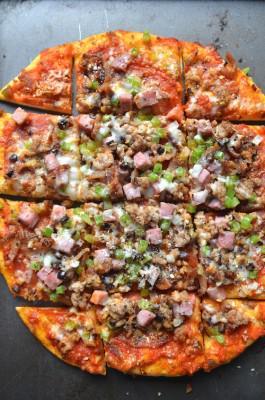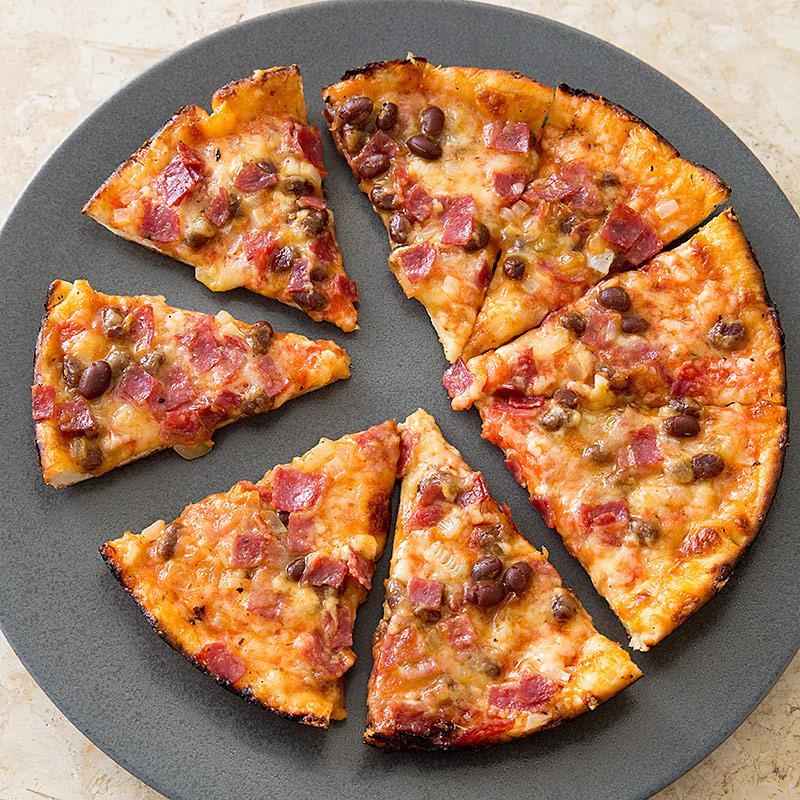The first image is the image on the left, the second image is the image on the right. For the images shown, is this caption "Each of the pizzas has been cut into individual pieces." true? Answer yes or no. Yes. 